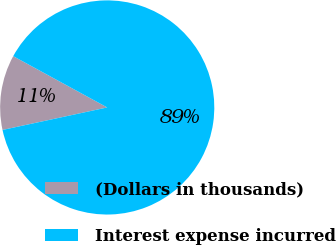Convert chart. <chart><loc_0><loc_0><loc_500><loc_500><pie_chart><fcel>(Dollars in thousands)<fcel>Interest expense incurred<nl><fcel>11.32%<fcel>88.68%<nl></chart> 